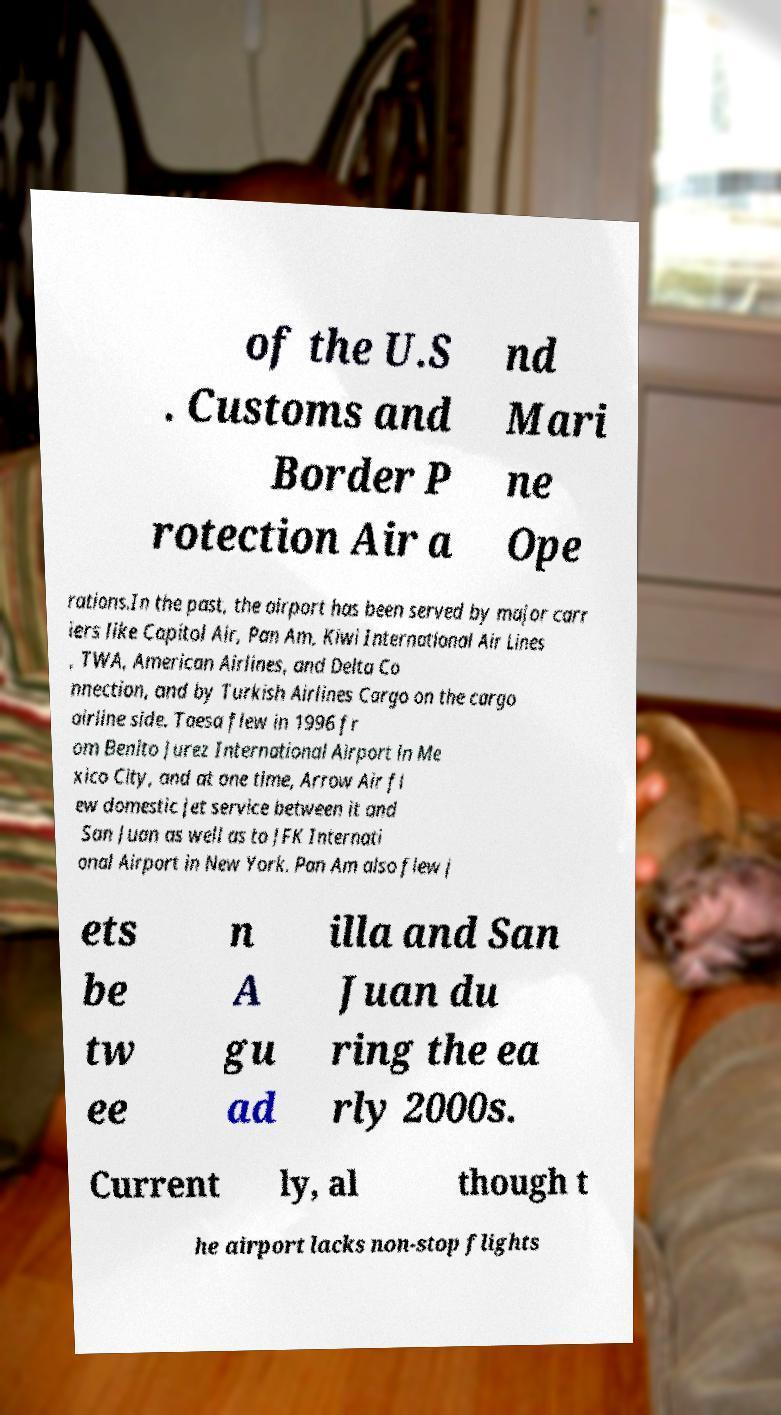Please identify and transcribe the text found in this image. of the U.S . Customs and Border P rotection Air a nd Mari ne Ope rations.In the past, the airport has been served by major carr iers like Capitol Air, Pan Am, Kiwi International Air Lines , TWA, American Airlines, and Delta Co nnection, and by Turkish Airlines Cargo on the cargo airline side. Taesa flew in 1996 fr om Benito Jurez International Airport in Me xico City, and at one time, Arrow Air fl ew domestic jet service between it and San Juan as well as to JFK Internati onal Airport in New York. Pan Am also flew j ets be tw ee n A gu ad illa and San Juan du ring the ea rly 2000s. Current ly, al though t he airport lacks non-stop flights 